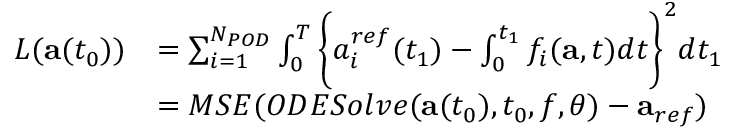<formula> <loc_0><loc_0><loc_500><loc_500>\begin{array} { r l } { L ( a ( t _ { 0 } ) ) } & { = \sum _ { i = 1 } ^ { N _ { P O D } } \int _ { 0 } ^ { T } \left \{ { a _ { i } ^ { r e f } } ( t _ { 1 } ) - \int _ { 0 } ^ { t _ { 1 } } f _ { i } ( a , t ) d t \right \} ^ { 2 } d t _ { 1 } } \\ & { = M S E ( O D E S o l v e ( a ( t _ { 0 } ) , t _ { 0 } , f , \theta ) - a _ { r e f } ) } \end{array}</formula> 